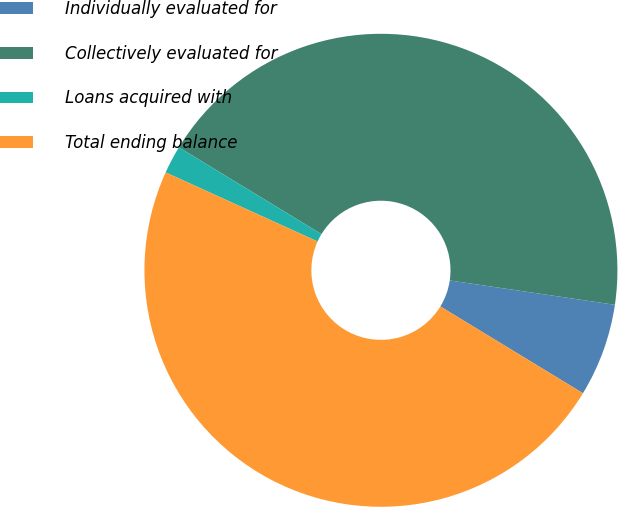Convert chart. <chart><loc_0><loc_0><loc_500><loc_500><pie_chart><fcel>Individually evaluated for<fcel>Collectively evaluated for<fcel>Loans acquired with<fcel>Total ending balance<nl><fcel>6.37%<fcel>43.63%<fcel>1.91%<fcel>48.09%<nl></chart> 